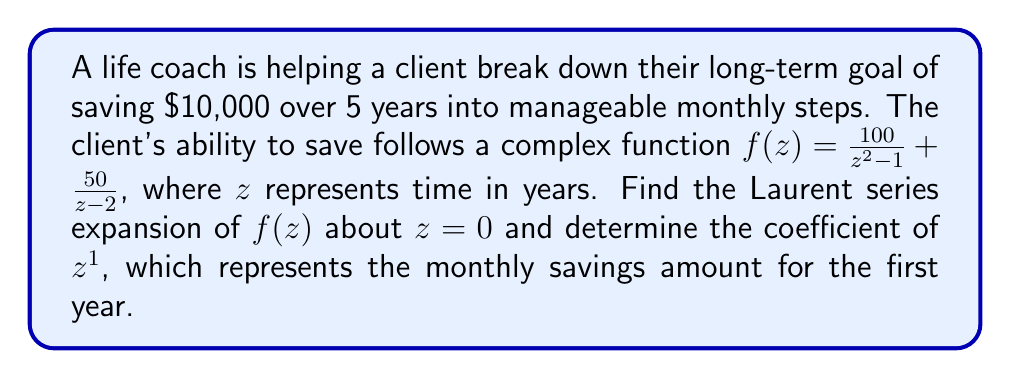Can you answer this question? Let's approach this step-by-step:

1) We need to find the Laurent series expansion of $f(z) = \frac{100}{z^2 - 1} + \frac{50}{z - 2}$ about $z=0$.

2) First, let's consider $\frac{100}{z^2 - 1}$:
   $$\frac{100}{z^2 - 1} = -100 \cdot \frac{1}{1-z^2} = -100(1 + z^2 + z^4 + ...)$$
   This is a geometric series with ratio $z^2$.

3) Now, for $\frac{50}{z - 2}$:
   $$\frac{50}{z - 2} = -25 \cdot \frac{1}{1-\frac{z}{2}} = -25(1 + \frac{z}{2} + \frac{z^2}{4} + \frac{z^3}{8} + ...)$$
   This is a geometric series with ratio $\frac{z}{2}$.

4) Combining these series:
   $$f(z) = (-100 - 25) + (-25 \cdot \frac{1}{2})z + (-25 \cdot \frac{1}{4})z^2 + (-25 \cdot \frac{1}{8})z^3 + (-100 + -25 \cdot \frac{1}{16})z^4 + ...$$

5) Simplifying:
   $$f(z) = -125 - 12.5z - 6.25z^2 - 3.125z^3 - 100.15625z^4 + ...$$

6) The coefficient of $z^1$ is -12.5.

7) Since this represents the monthly savings for the first year, we need to multiply by 12 to get the annual amount:
   $-12.5 * 12 = -150$

8) The negative sign indicates that this is the amount the client needs to save each year.
Answer: $150 per year 